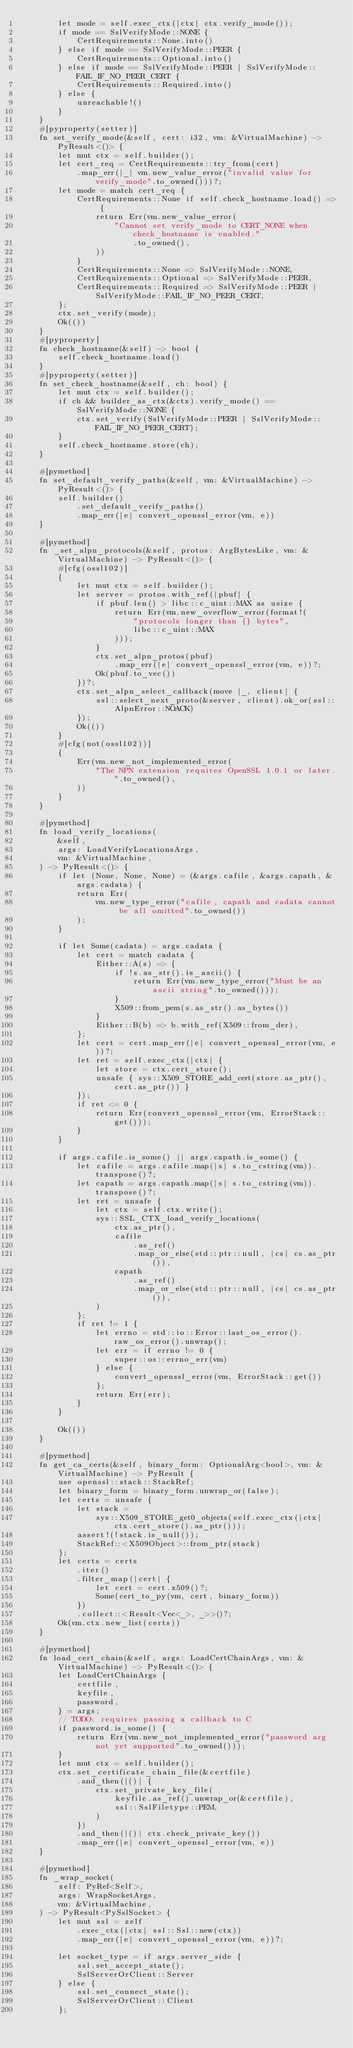<code> <loc_0><loc_0><loc_500><loc_500><_Rust_>        let mode = self.exec_ctx(|ctx| ctx.verify_mode());
        if mode == SslVerifyMode::NONE {
            CertRequirements::None.into()
        } else if mode == SslVerifyMode::PEER {
            CertRequirements::Optional.into()
        } else if mode == SslVerifyMode::PEER | SslVerifyMode::FAIL_IF_NO_PEER_CERT {
            CertRequirements::Required.into()
        } else {
            unreachable!()
        }
    }
    #[pyproperty(setter)]
    fn set_verify_mode(&self, cert: i32, vm: &VirtualMachine) -> PyResult<()> {
        let mut ctx = self.builder();
        let cert_req = CertRequirements::try_from(cert)
            .map_err(|_| vm.new_value_error("invalid value for verify_mode".to_owned()))?;
        let mode = match cert_req {
            CertRequirements::None if self.check_hostname.load() => {
                return Err(vm.new_value_error(
                    "Cannot set verify_mode to CERT_NONE when check_hostname is enabled."
                        .to_owned(),
                ))
            }
            CertRequirements::None => SslVerifyMode::NONE,
            CertRequirements::Optional => SslVerifyMode::PEER,
            CertRequirements::Required => SslVerifyMode::PEER | SslVerifyMode::FAIL_IF_NO_PEER_CERT,
        };
        ctx.set_verify(mode);
        Ok(())
    }
    #[pyproperty]
    fn check_hostname(&self) -> bool {
        self.check_hostname.load()
    }
    #[pyproperty(setter)]
    fn set_check_hostname(&self, ch: bool) {
        let mut ctx = self.builder();
        if ch && builder_as_ctx(&ctx).verify_mode() == SslVerifyMode::NONE {
            ctx.set_verify(SslVerifyMode::PEER | SslVerifyMode::FAIL_IF_NO_PEER_CERT);
        }
        self.check_hostname.store(ch);
    }

    #[pymethod]
    fn set_default_verify_paths(&self, vm: &VirtualMachine) -> PyResult<()> {
        self.builder()
            .set_default_verify_paths()
            .map_err(|e| convert_openssl_error(vm, e))
    }

    #[pymethod]
    fn _set_alpn_protocols(&self, protos: ArgBytesLike, vm: &VirtualMachine) -> PyResult<()> {
        #[cfg(ossl102)]
        {
            let mut ctx = self.builder();
            let server = protos.with_ref(|pbuf| {
                if pbuf.len() > libc::c_uint::MAX as usize {
                    return Err(vm.new_overflow_error(format!(
                        "protocols longer than {} bytes",
                        libc::c_uint::MAX
                    )));
                }
                ctx.set_alpn_protos(pbuf)
                    .map_err(|e| convert_openssl_error(vm, e))?;
                Ok(pbuf.to_vec())
            })?;
            ctx.set_alpn_select_callback(move |_, client| {
                ssl::select_next_proto(&server, client).ok_or(ssl::AlpnError::NOACK)
            });
            Ok(())
        }
        #[cfg(not(ossl102))]
        {
            Err(vm.new_not_implemented_error(
                "The NPN extension requires OpenSSL 1.0.1 or later.".to_owned(),
            ))
        }
    }

    #[pymethod]
    fn load_verify_locations(
        &self,
        args: LoadVerifyLocationsArgs,
        vm: &VirtualMachine,
    ) -> PyResult<()> {
        if let (None, None, None) = (&args.cafile, &args.capath, &args.cadata) {
            return Err(
                vm.new_type_error("cafile, capath and cadata cannot be all omitted".to_owned())
            );
        }

        if let Some(cadata) = args.cadata {
            let cert = match cadata {
                Either::A(s) => {
                    if !s.as_str().is_ascii() {
                        return Err(vm.new_type_error("Must be an ascii string".to_owned()));
                    }
                    X509::from_pem(s.as_str().as_bytes())
                }
                Either::B(b) => b.with_ref(X509::from_der),
            };
            let cert = cert.map_err(|e| convert_openssl_error(vm, e))?;
            let ret = self.exec_ctx(|ctx| {
                let store = ctx.cert_store();
                unsafe { sys::X509_STORE_add_cert(store.as_ptr(), cert.as_ptr()) }
            });
            if ret <= 0 {
                return Err(convert_openssl_error(vm, ErrorStack::get()));
            }
        }

        if args.cafile.is_some() || args.capath.is_some() {
            let cafile = args.cafile.map(|s| s.to_cstring(vm)).transpose()?;
            let capath = args.capath.map(|s| s.to_cstring(vm)).transpose()?;
            let ret = unsafe {
                let ctx = self.ctx.write();
                sys::SSL_CTX_load_verify_locations(
                    ctx.as_ptr(),
                    cafile
                        .as_ref()
                        .map_or_else(std::ptr::null, |cs| cs.as_ptr()),
                    capath
                        .as_ref()
                        .map_or_else(std::ptr::null, |cs| cs.as_ptr()),
                )
            };
            if ret != 1 {
                let errno = std::io::Error::last_os_error().raw_os_error().unwrap();
                let err = if errno != 0 {
                    super::os::errno_err(vm)
                } else {
                    convert_openssl_error(vm, ErrorStack::get())
                };
                return Err(err);
            }
        }

        Ok(())
    }

    #[pymethod]
    fn get_ca_certs(&self, binary_form: OptionalArg<bool>, vm: &VirtualMachine) -> PyResult {
        use openssl::stack::StackRef;
        let binary_form = binary_form.unwrap_or(false);
        let certs = unsafe {
            let stack =
                sys::X509_STORE_get0_objects(self.exec_ctx(|ctx| ctx.cert_store().as_ptr()));
            assert!(!stack.is_null());
            StackRef::<X509Object>::from_ptr(stack)
        };
        let certs = certs
            .iter()
            .filter_map(|cert| {
                let cert = cert.x509()?;
                Some(cert_to_py(vm, cert, binary_form))
            })
            .collect::<Result<Vec<_>, _>>()?;
        Ok(vm.ctx.new_list(certs))
    }

    #[pymethod]
    fn load_cert_chain(&self, args: LoadCertChainArgs, vm: &VirtualMachine) -> PyResult<()> {
        let LoadCertChainArgs {
            certfile,
            keyfile,
            password,
        } = args;
        // TODO: requires passing a callback to C
        if password.is_some() {
            return Err(vm.new_not_implemented_error("password arg not yet supported".to_owned()));
        }
        let mut ctx = self.builder();
        ctx.set_certificate_chain_file(&certfile)
            .and_then(|()| {
                ctx.set_private_key_file(
                    keyfile.as_ref().unwrap_or(&certfile),
                    ssl::SslFiletype::PEM,
                )
            })
            .and_then(|()| ctx.check_private_key())
            .map_err(|e| convert_openssl_error(vm, e))
    }

    #[pymethod]
    fn _wrap_socket(
        zelf: PyRef<Self>,
        args: WrapSocketArgs,
        vm: &VirtualMachine,
    ) -> PyResult<PySslSocket> {
        let mut ssl = zelf
            .exec_ctx(|ctx| ssl::Ssl::new(ctx))
            .map_err(|e| convert_openssl_error(vm, e))?;

        let socket_type = if args.server_side {
            ssl.set_accept_state();
            SslServerOrClient::Server
        } else {
            ssl.set_connect_state();
            SslServerOrClient::Client
        };
</code> 